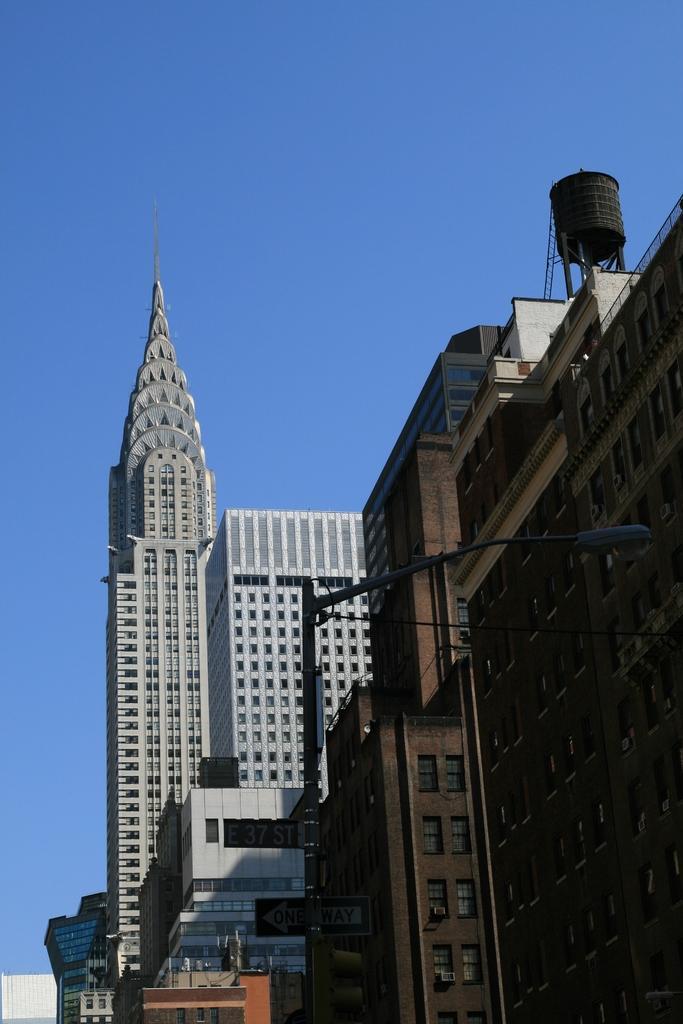Please provide a concise description of this image. In this image I can see the buildings with the windows with some text written on it. I can see an electric pole. At the top I can see the sky. 